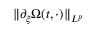Convert formula to latex. <formula><loc_0><loc_0><loc_500><loc_500>\| \partial _ { \xi } \Omega ( t , \cdot ) \| _ { L ^ { p } }</formula> 